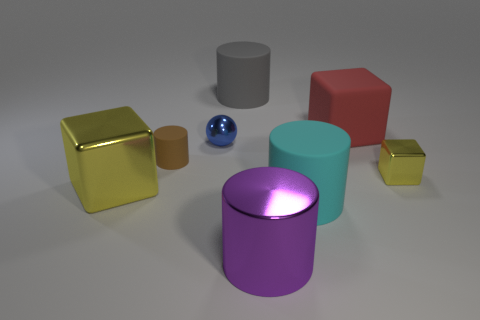Is there a thing of the same color as the small block?
Your response must be concise. Yes. The metal ball is what size?
Your answer should be very brief. Small. Is the color of the small cube the same as the large metal cube?
Provide a succinct answer. Yes. How many things are large brown cylinders or big rubber objects in front of the large yellow thing?
Your response must be concise. 1. How many small brown rubber objects are on the left side of the large block in front of the block that is to the right of the large red matte block?
Provide a short and direct response. 0. What number of cyan cylinders are there?
Offer a very short reply. 1. Do the cube that is behind the brown matte object and the cyan rubber object have the same size?
Make the answer very short. Yes. How many rubber things are yellow things or big cyan spheres?
Your response must be concise. 0. What number of gray cylinders are in front of the rubber thing left of the tiny ball?
Provide a short and direct response. 0. There is a rubber object that is behind the blue metallic thing and right of the big purple cylinder; what is its shape?
Provide a succinct answer. Cube. 